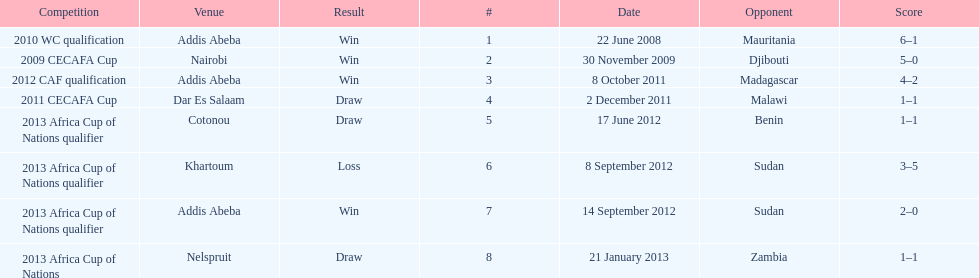How long in years down this table cover? 5. 